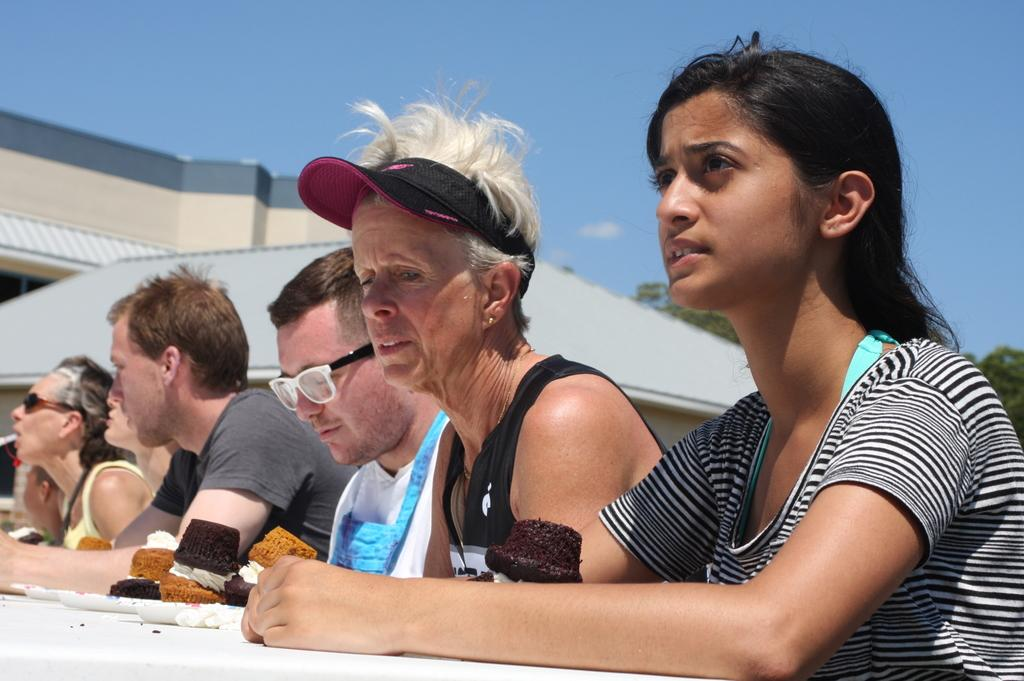How many people are in the image? There is a group of people in the image, but the exact number cannot be determined from the provided facts. What can be seen in the background of the image? There are buildings, trees, and the sky visible in the background of the image. What type of pest can be seen crawling on the prose in the image? There is no prose or pest present in the image. What type of rice is being served to the group of people in the image? There is no rice present in the image. 